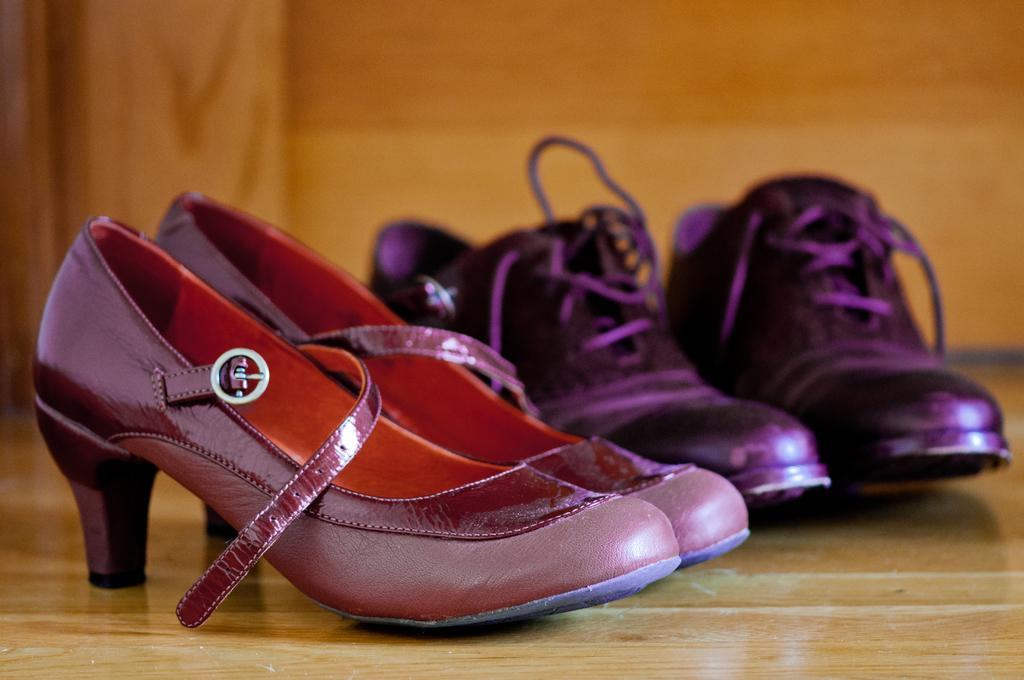What is the main subject in the center of the image? There are shoes in the center of the image. What feature do the shoes have? The shoes have laces. Where are the laces located? The laces are present on the surface of the shoes. What can be seen in the background of the image? There is a wall visible in the background of the image. What type of pen can be seen on the shoes in the image? There is no pen present on the shoes in the image. How many beans are visible on the shoes in the image? There are no beans present on the shoes in the image. 